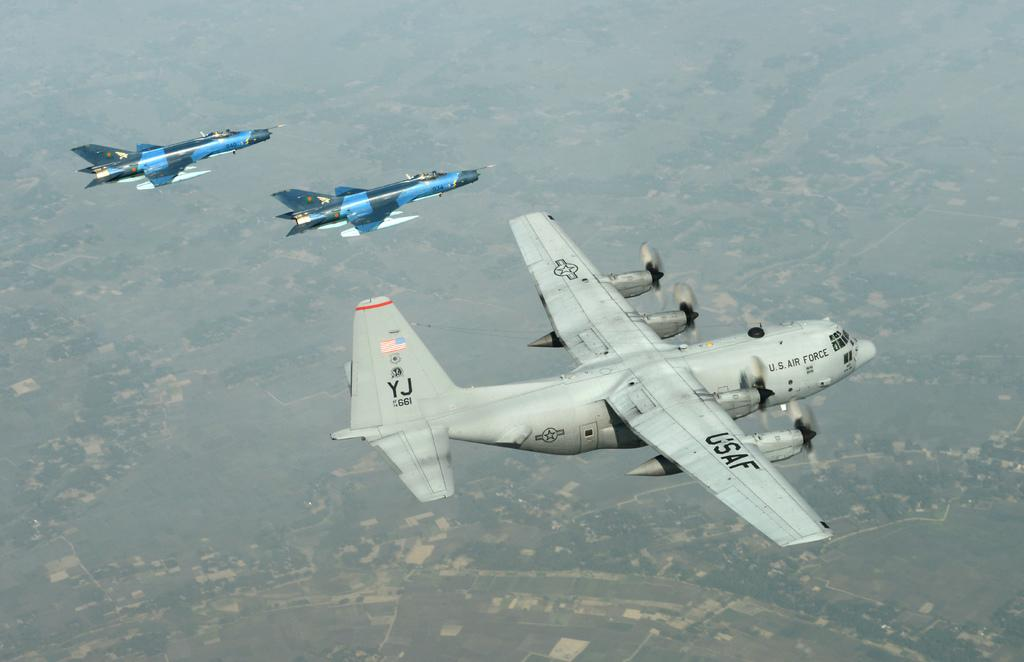<image>
Create a compact narrative representing the image presented. USAF air craft fly over the city with two other jets 